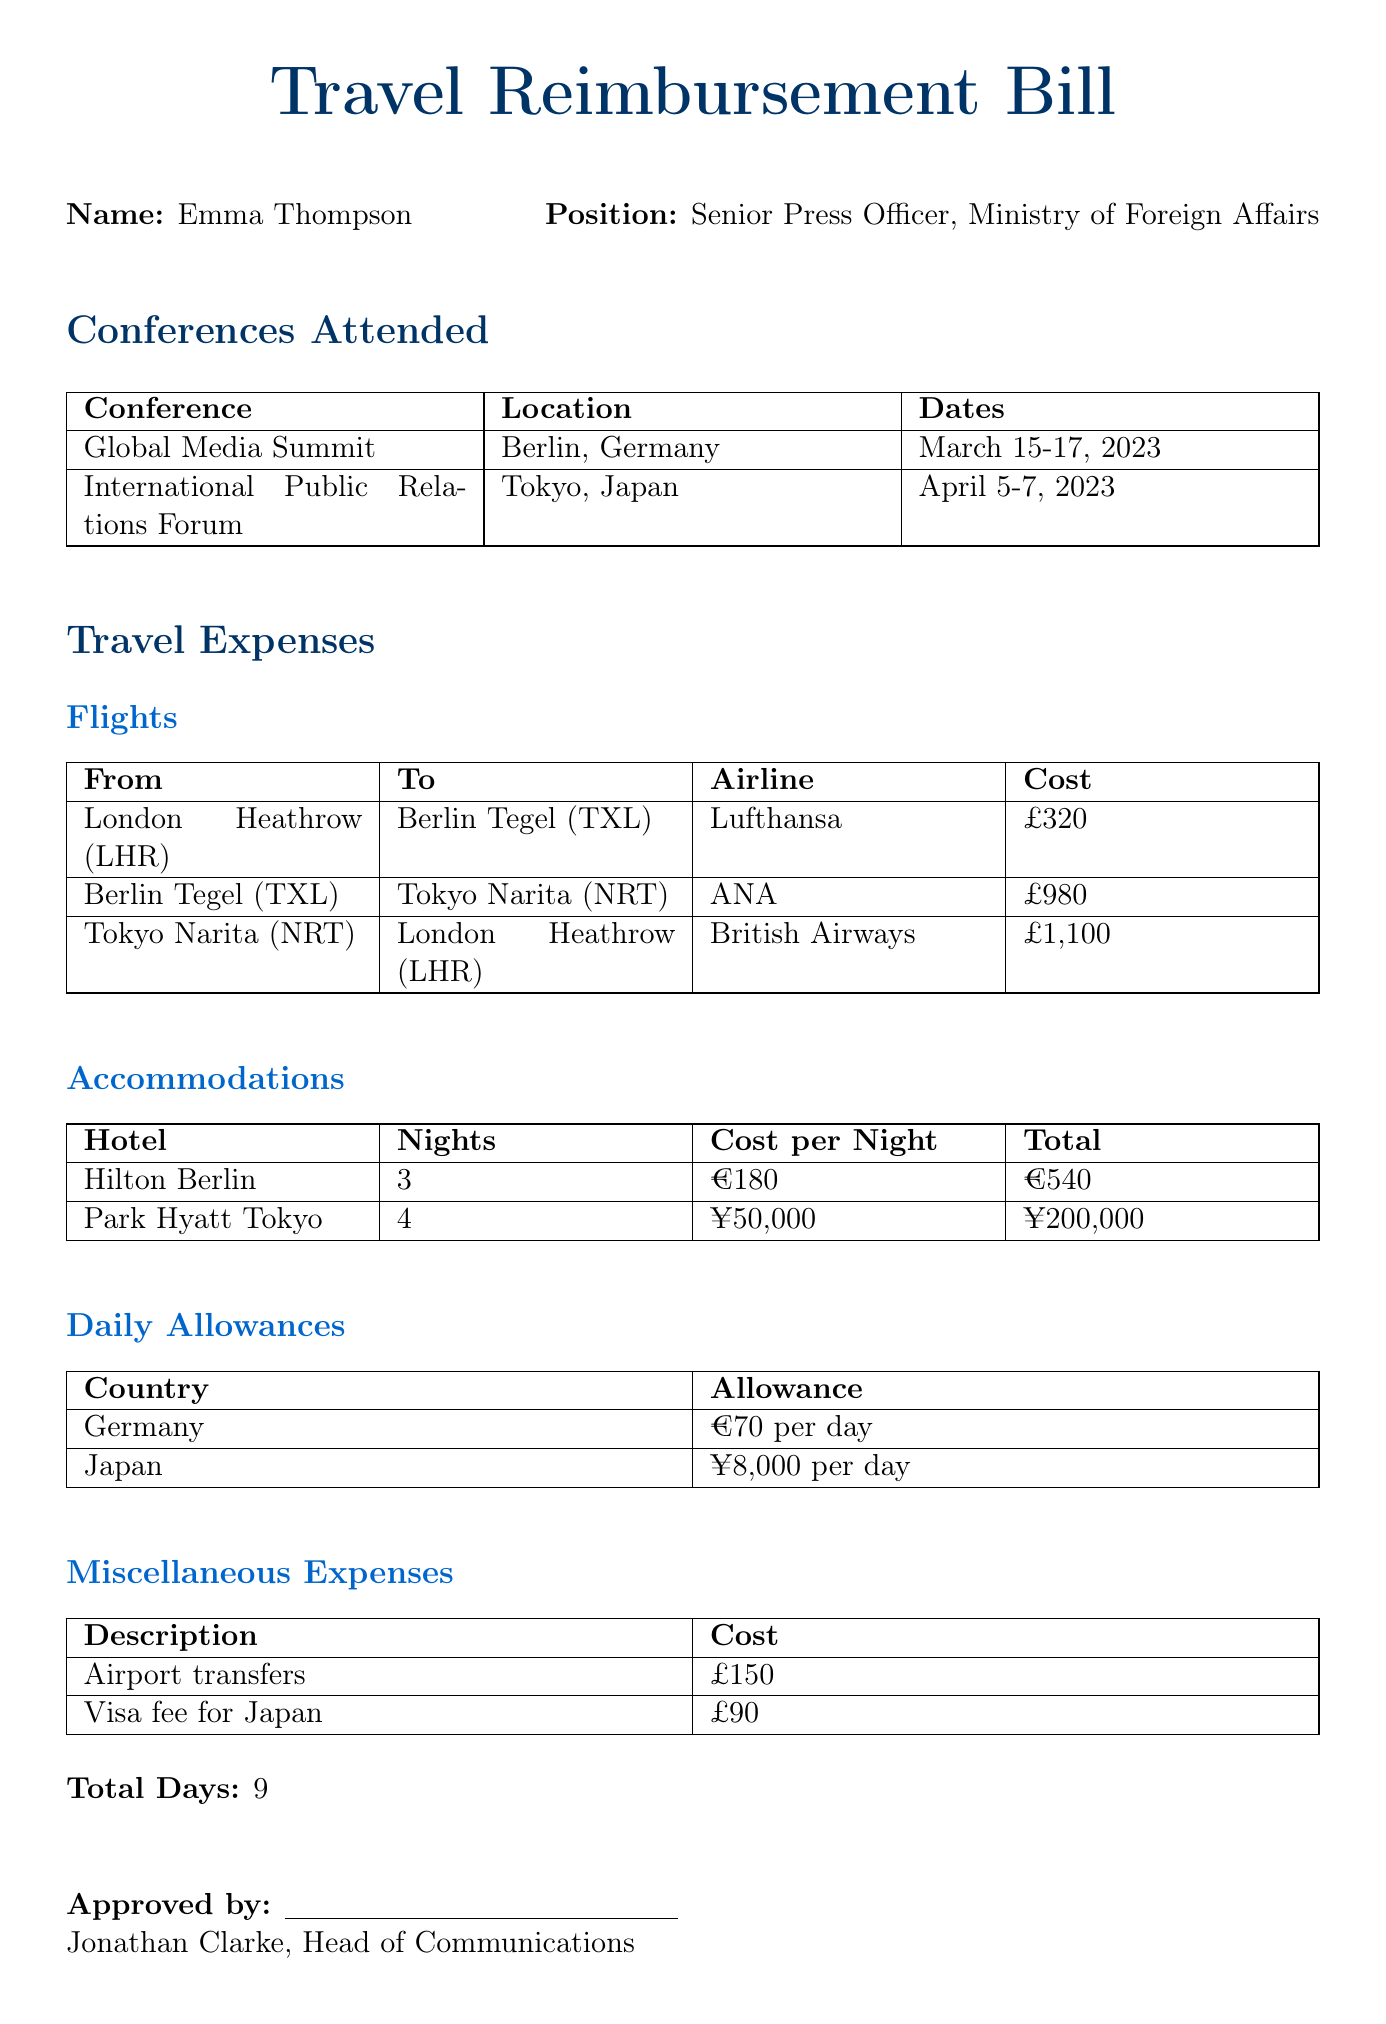What is the total cost for the flights? The total cost for flights is calculated by adding all individual flight costs: £320 + £980 + £1,100 = £2,400.
Answer: £2,400 How many nights did Emma stay at the Park Hyatt Tokyo? The document specifies that Emma stayed for 4 nights at the Park Hyatt Tokyo.
Answer: 4 What is the daily allowance in Japan? The document states that the allowance for Japan is ¥8,000 per day.
Answer: ¥8,000 per day Who is the approved by signature in the document? The document lists Jonathan Clarke as the person who approved the travel reimbursement bill.
Answer: Jonathan Clarke What is the total number of days attended for conferences? The document summarizes that Emma attended conferences for a total of 9 days.
Answer: 9 What is the total accommodation cost in Berlin? The total accommodation cost in Berlin is stated as €540 for 3 nights at the Hilton Berlin.
Answer: €540 Which airline was used for the flight from Tokyo to London? The document indicates that the airline for the flight from Tokyo to London is British Airways.
Answer: British Airways What is the visa fee for Japan? The document lists the visa fee for Japan as £90.
Answer: £90 